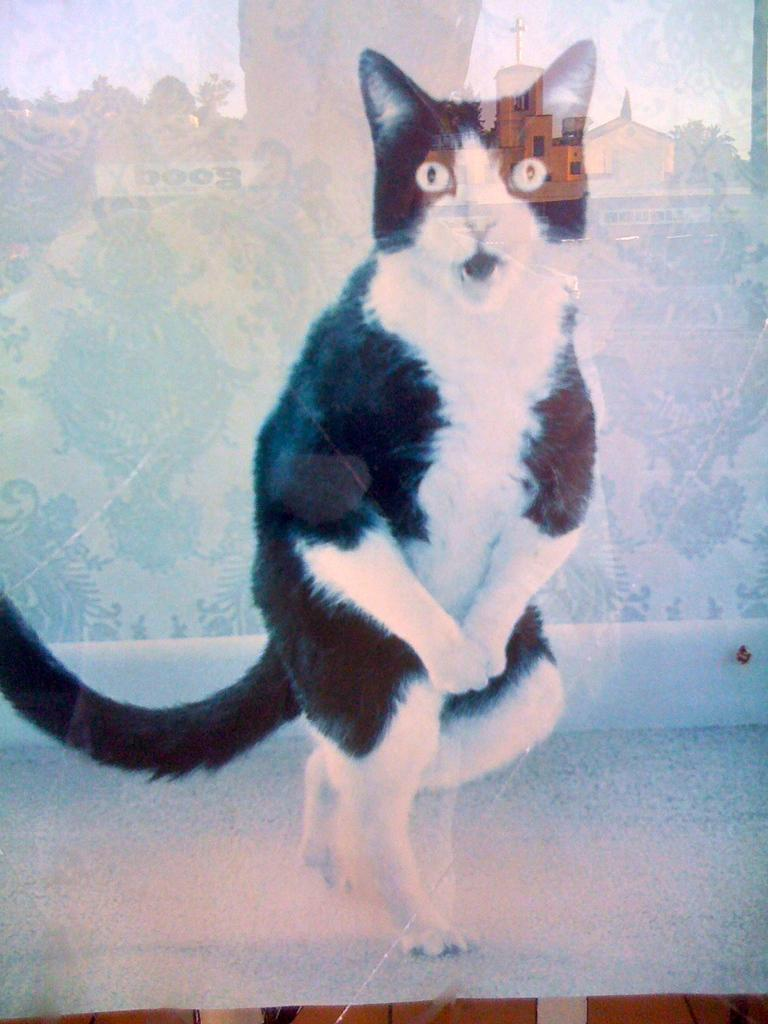What is depicted in the photo frame in the image? There is a photo frame of a cat in the image. What material is used for the front of the photo frame? The photo frame has glass. What can be seen reflected on the glass of the photo frame? There are reflections of a person, trees, buildings, and the sky on the glass. What type of seed is being used to stir the cat's food in the image? There is no seed or cat food present in the image; it only features a photo frame of a cat with reflections on the glass. 